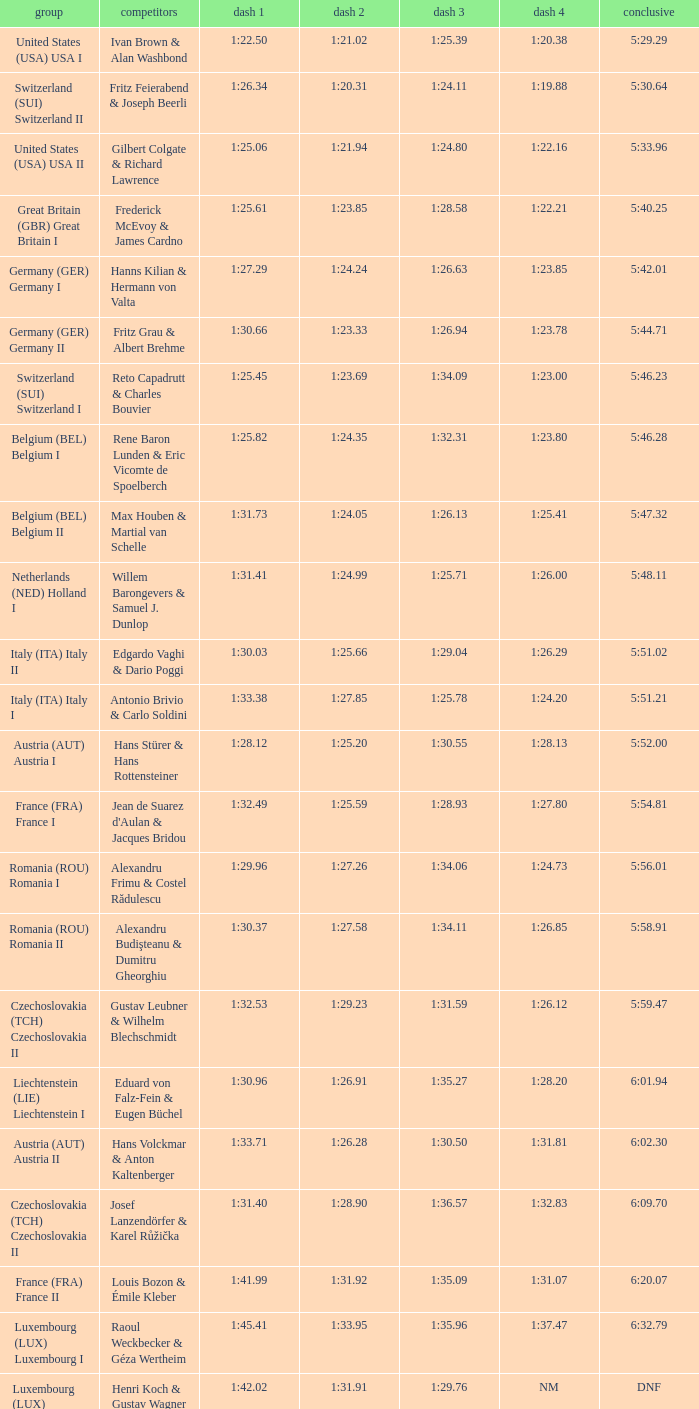Which Run 4 has a Run 1 of 1:25.82? 1:23.80. 